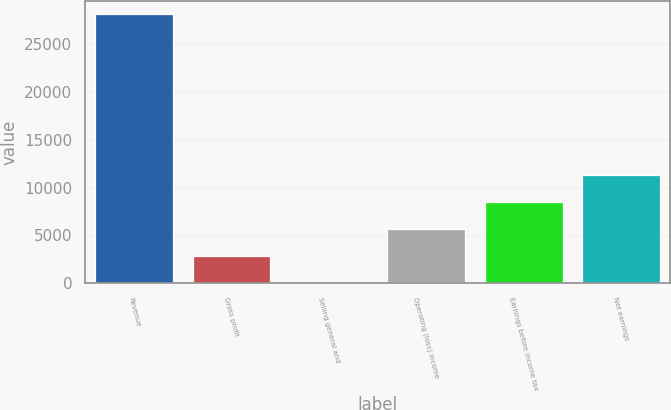Convert chart to OTSL. <chart><loc_0><loc_0><loc_500><loc_500><bar_chart><fcel>Revenue<fcel>Gross profit<fcel>Selling general and<fcel>Operating (loss) income<fcel>Earnings before income tax<fcel>Net earnings<nl><fcel>28120<fcel>2830.9<fcel>21<fcel>5640.8<fcel>8450.7<fcel>11260.6<nl></chart> 